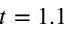Convert formula to latex. <formula><loc_0><loc_0><loc_500><loc_500>t = 1 . 1</formula> 